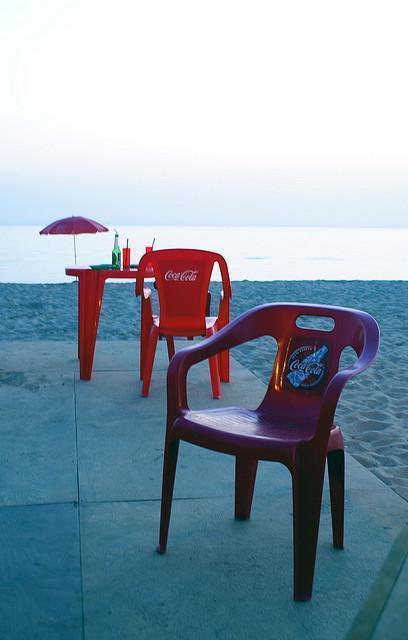What drink brand is seen on the chairs?
Choose the right answer and clarify with the format: 'Answer: answer
Rationale: rationale.'
Options: Coca cola, pepsi, sprite, canada dry. Answer: coca cola.
Rationale: The brand is coke. 